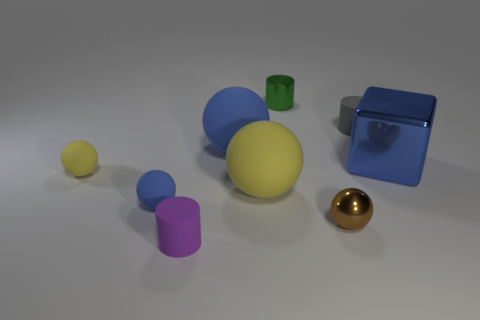Subtract 1 balls. How many balls are left? 4 Subtract all blue balls. How many balls are left? 3 Subtract all tiny shiny balls. How many balls are left? 4 Subtract all green spheres. Subtract all purple cylinders. How many spheres are left? 5 Add 1 big blocks. How many objects exist? 10 Subtract all balls. How many objects are left? 4 Subtract all small blue matte cylinders. Subtract all gray rubber cylinders. How many objects are left? 8 Add 5 big yellow balls. How many big yellow balls are left? 6 Add 9 small shiny cylinders. How many small shiny cylinders exist? 10 Subtract 0 red blocks. How many objects are left? 9 